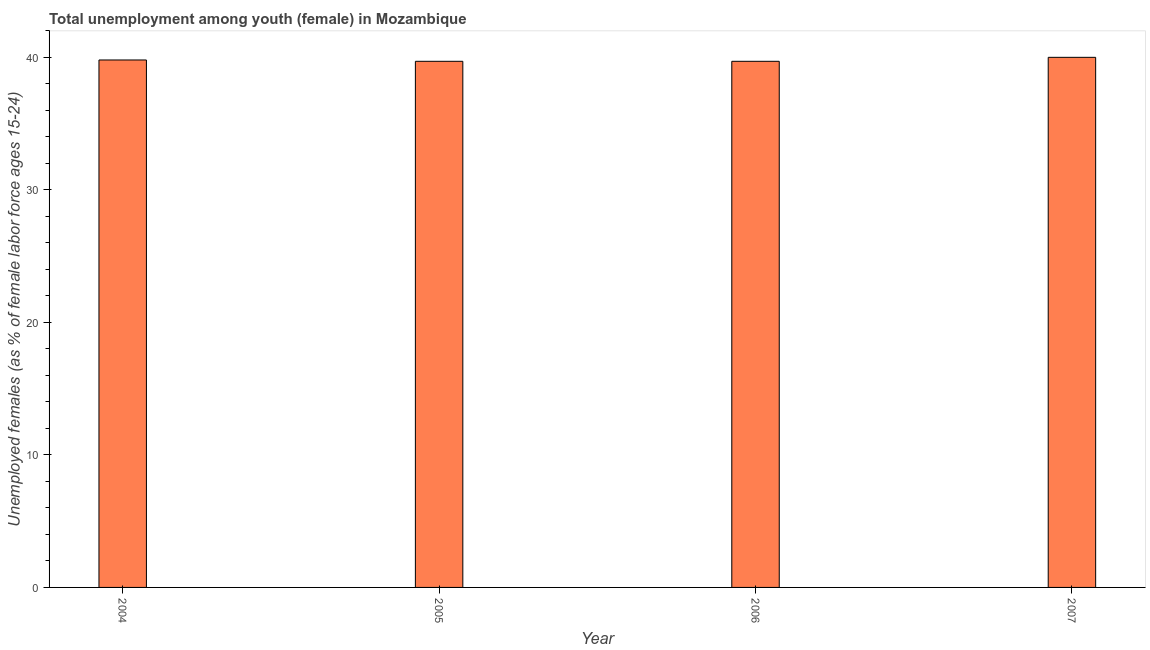Does the graph contain any zero values?
Keep it short and to the point. No. What is the title of the graph?
Make the answer very short. Total unemployment among youth (female) in Mozambique. What is the label or title of the X-axis?
Your response must be concise. Year. What is the label or title of the Y-axis?
Provide a short and direct response. Unemployed females (as % of female labor force ages 15-24). What is the unemployed female youth population in 2004?
Offer a very short reply. 39.8. Across all years, what is the minimum unemployed female youth population?
Give a very brief answer. 39.7. In which year was the unemployed female youth population maximum?
Your answer should be compact. 2007. What is the sum of the unemployed female youth population?
Provide a short and direct response. 159.2. What is the difference between the unemployed female youth population in 2005 and 2007?
Your answer should be compact. -0.3. What is the average unemployed female youth population per year?
Offer a very short reply. 39.8. What is the median unemployed female youth population?
Your answer should be very brief. 39.75. In how many years, is the unemployed female youth population greater than 34 %?
Your answer should be very brief. 4. Do a majority of the years between 2004 and 2005 (inclusive) have unemployed female youth population greater than 34 %?
Offer a terse response. Yes. What is the ratio of the unemployed female youth population in 2005 to that in 2006?
Offer a very short reply. 1. Is the difference between the unemployed female youth population in 2005 and 2007 greater than the difference between any two years?
Your answer should be very brief. Yes. What is the difference between the highest and the lowest unemployed female youth population?
Your response must be concise. 0.3. Are all the bars in the graph horizontal?
Provide a succinct answer. No. How many years are there in the graph?
Keep it short and to the point. 4. Are the values on the major ticks of Y-axis written in scientific E-notation?
Provide a short and direct response. No. What is the Unemployed females (as % of female labor force ages 15-24) of 2004?
Your answer should be very brief. 39.8. What is the Unemployed females (as % of female labor force ages 15-24) of 2005?
Your answer should be very brief. 39.7. What is the Unemployed females (as % of female labor force ages 15-24) in 2006?
Offer a very short reply. 39.7. What is the difference between the Unemployed females (as % of female labor force ages 15-24) in 2004 and 2005?
Provide a succinct answer. 0.1. What is the difference between the Unemployed females (as % of female labor force ages 15-24) in 2004 and 2006?
Your answer should be compact. 0.1. What is the difference between the Unemployed females (as % of female labor force ages 15-24) in 2004 and 2007?
Provide a succinct answer. -0.2. What is the difference between the Unemployed females (as % of female labor force ages 15-24) in 2005 and 2007?
Your answer should be compact. -0.3. What is the ratio of the Unemployed females (as % of female labor force ages 15-24) in 2004 to that in 2006?
Your answer should be very brief. 1. What is the ratio of the Unemployed females (as % of female labor force ages 15-24) in 2004 to that in 2007?
Provide a succinct answer. 0.99. 